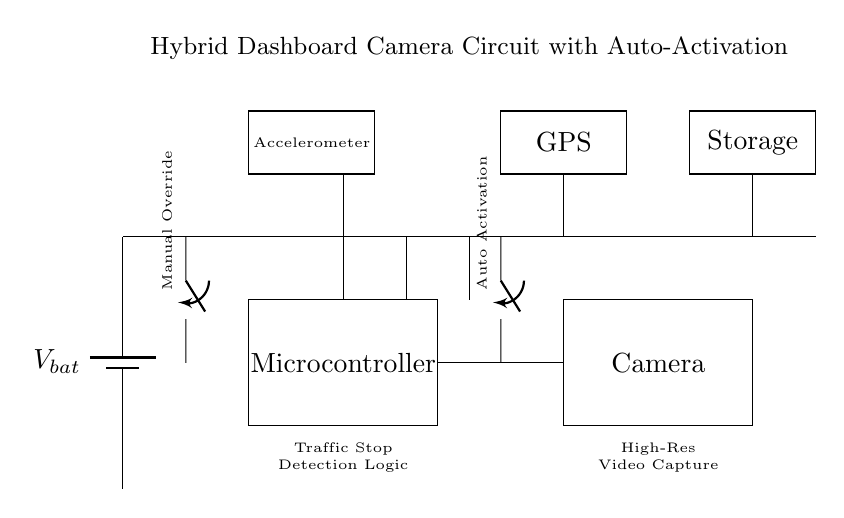What is the function of the microcontroller in this circuit? The microcontroller acts as the central processing unit, managing the signals from the other components and controlling the camera and auto activation logic during traffic stops.
Answer: Central processing unit What components are connected to power through the same line? The components connected to power through the same line include the microcontroller, camera, and GPS, which are all powered by the battery supplied voltage.
Answer: Microcontroller, camera, GPS What type of switch is used for manual override? The circuit uses a single-pole, single-throw switch for manual override control to activate or deactivate the system when desired.
Answer: Single-pole, single-throw How does the auto activation feature work? The auto activation feature is controlled by the second switch connected to the traffic stop detection logic. When triggered by the logic detecting a traffic stop, this switch activates the system automatically.
Answer: Traffic stop detection logic How many sensors are present in the circuit? There are two sensors in the circuit: an accelerometer for motion sensing and a GPS module for location tracking.
Answer: Two sensors 